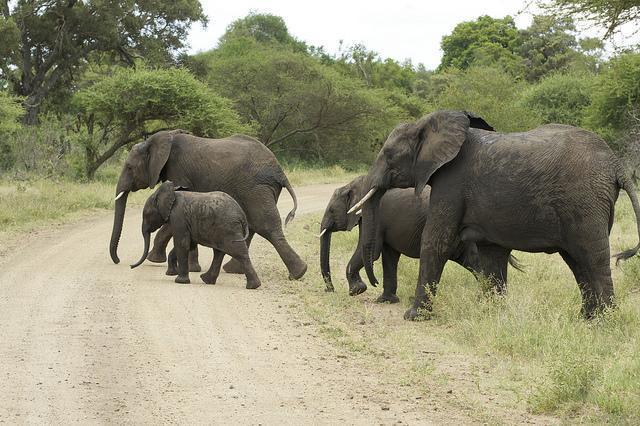How many animals?
Give a very brief answer. 4. How many elephants are there?
Give a very brief answer. 4. How many elephants are in the photo?
Give a very brief answer. 4. 